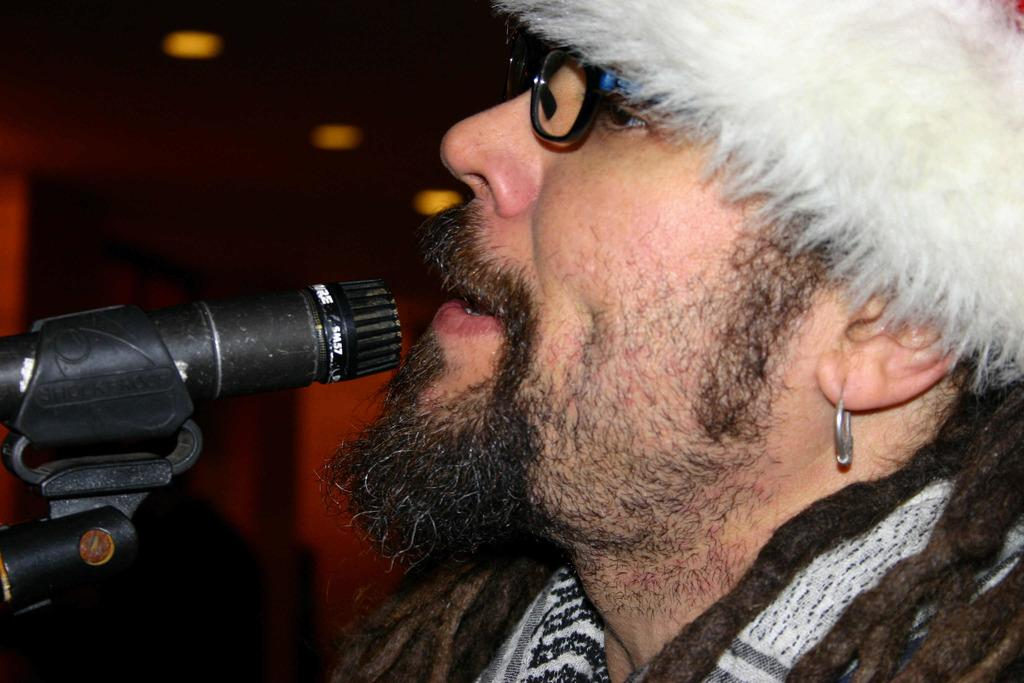Who is the main subject in the image? There is a man in the image. What can be seen on the man's face? The man is wearing spectacles. What object is in front of the man? There is a microphone in front of the man. What is the color of the background in the background of the image? The background of the image is dark. What type of leaf is falling from the scarecrow in the image? There is no scarecrow or leaf present in the image. 